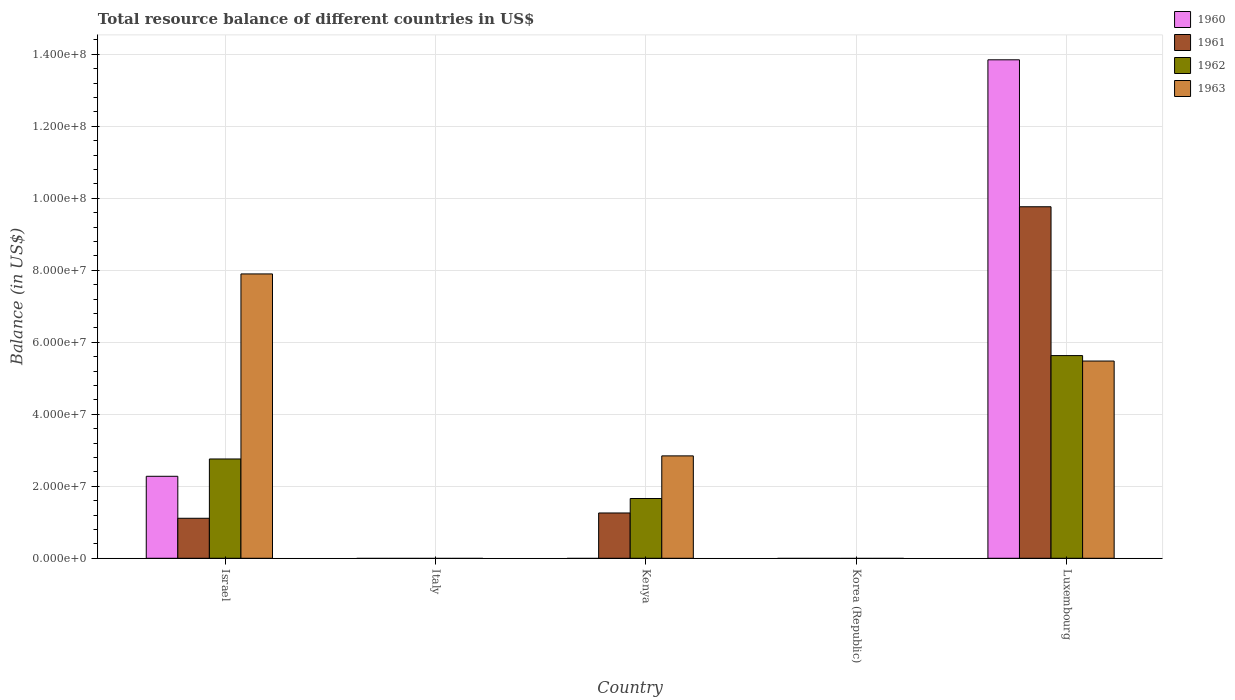Are the number of bars per tick equal to the number of legend labels?
Make the answer very short. No. What is the label of the 3rd group of bars from the left?
Provide a short and direct response. Kenya. What is the total resource balance in 1962 in Kenya?
Your answer should be very brief. 1.66e+07. Across all countries, what is the maximum total resource balance in 1962?
Keep it short and to the point. 5.63e+07. In which country was the total resource balance in 1960 maximum?
Provide a succinct answer. Luxembourg. What is the total total resource balance in 1961 in the graph?
Ensure brevity in your answer.  1.21e+08. What is the difference between the total resource balance in 1961 in Israel and that in Kenya?
Provide a short and direct response. -1.47e+06. What is the average total resource balance in 1960 per country?
Your response must be concise. 3.23e+07. What is the difference between the total resource balance of/in 1962 and total resource balance of/in 1961 in Israel?
Keep it short and to the point. 1.65e+07. What is the ratio of the total resource balance in 1963 in Kenya to that in Luxembourg?
Ensure brevity in your answer.  0.52. What is the difference between the highest and the second highest total resource balance in 1963?
Offer a terse response. 5.06e+07. What is the difference between the highest and the lowest total resource balance in 1961?
Your answer should be very brief. 9.77e+07. In how many countries, is the total resource balance in 1961 greater than the average total resource balance in 1961 taken over all countries?
Offer a terse response. 1. Is it the case that in every country, the sum of the total resource balance in 1962 and total resource balance in 1963 is greater than the sum of total resource balance in 1961 and total resource balance in 1960?
Ensure brevity in your answer.  No. Is it the case that in every country, the sum of the total resource balance in 1960 and total resource balance in 1961 is greater than the total resource balance in 1963?
Your response must be concise. No. How many bars are there?
Give a very brief answer. 11. Are all the bars in the graph horizontal?
Make the answer very short. No. How many countries are there in the graph?
Offer a terse response. 5. What is the difference between two consecutive major ticks on the Y-axis?
Your response must be concise. 2.00e+07. Are the values on the major ticks of Y-axis written in scientific E-notation?
Your answer should be compact. Yes. Does the graph contain any zero values?
Your answer should be very brief. Yes. Does the graph contain grids?
Your response must be concise. Yes. How many legend labels are there?
Provide a short and direct response. 4. What is the title of the graph?
Provide a short and direct response. Total resource balance of different countries in US$. What is the label or title of the X-axis?
Your answer should be very brief. Country. What is the label or title of the Y-axis?
Offer a very short reply. Balance (in US$). What is the Balance (in US$) in 1960 in Israel?
Give a very brief answer. 2.28e+07. What is the Balance (in US$) of 1961 in Israel?
Ensure brevity in your answer.  1.11e+07. What is the Balance (in US$) in 1962 in Israel?
Offer a terse response. 2.76e+07. What is the Balance (in US$) of 1963 in Israel?
Provide a short and direct response. 7.90e+07. What is the Balance (in US$) in 1961 in Italy?
Your response must be concise. 0. What is the Balance (in US$) of 1963 in Italy?
Offer a very short reply. 0. What is the Balance (in US$) of 1961 in Kenya?
Your answer should be compact. 1.26e+07. What is the Balance (in US$) in 1962 in Kenya?
Your answer should be very brief. 1.66e+07. What is the Balance (in US$) in 1963 in Kenya?
Ensure brevity in your answer.  2.84e+07. What is the Balance (in US$) of 1963 in Korea (Republic)?
Give a very brief answer. 0. What is the Balance (in US$) of 1960 in Luxembourg?
Your answer should be very brief. 1.38e+08. What is the Balance (in US$) in 1961 in Luxembourg?
Offer a terse response. 9.77e+07. What is the Balance (in US$) of 1962 in Luxembourg?
Provide a succinct answer. 5.63e+07. What is the Balance (in US$) of 1963 in Luxembourg?
Keep it short and to the point. 5.48e+07. Across all countries, what is the maximum Balance (in US$) in 1960?
Your answer should be compact. 1.38e+08. Across all countries, what is the maximum Balance (in US$) in 1961?
Offer a very short reply. 9.77e+07. Across all countries, what is the maximum Balance (in US$) in 1962?
Provide a succinct answer. 5.63e+07. Across all countries, what is the maximum Balance (in US$) of 1963?
Your answer should be very brief. 7.90e+07. Across all countries, what is the minimum Balance (in US$) of 1960?
Offer a terse response. 0. Across all countries, what is the minimum Balance (in US$) in 1962?
Your answer should be compact. 0. Across all countries, what is the minimum Balance (in US$) in 1963?
Your answer should be very brief. 0. What is the total Balance (in US$) in 1960 in the graph?
Provide a short and direct response. 1.61e+08. What is the total Balance (in US$) in 1961 in the graph?
Offer a terse response. 1.21e+08. What is the total Balance (in US$) of 1962 in the graph?
Ensure brevity in your answer.  1.01e+08. What is the total Balance (in US$) in 1963 in the graph?
Provide a short and direct response. 1.62e+08. What is the difference between the Balance (in US$) of 1961 in Israel and that in Kenya?
Offer a terse response. -1.47e+06. What is the difference between the Balance (in US$) in 1962 in Israel and that in Kenya?
Provide a succinct answer. 1.10e+07. What is the difference between the Balance (in US$) of 1963 in Israel and that in Kenya?
Offer a terse response. 5.06e+07. What is the difference between the Balance (in US$) of 1960 in Israel and that in Luxembourg?
Keep it short and to the point. -1.16e+08. What is the difference between the Balance (in US$) of 1961 in Israel and that in Luxembourg?
Offer a terse response. -8.66e+07. What is the difference between the Balance (in US$) in 1962 in Israel and that in Luxembourg?
Your response must be concise. -2.87e+07. What is the difference between the Balance (in US$) of 1963 in Israel and that in Luxembourg?
Offer a terse response. 2.42e+07. What is the difference between the Balance (in US$) in 1961 in Kenya and that in Luxembourg?
Provide a succinct answer. -8.51e+07. What is the difference between the Balance (in US$) in 1962 in Kenya and that in Luxembourg?
Offer a terse response. -3.97e+07. What is the difference between the Balance (in US$) in 1963 in Kenya and that in Luxembourg?
Your answer should be very brief. -2.64e+07. What is the difference between the Balance (in US$) of 1960 in Israel and the Balance (in US$) of 1961 in Kenya?
Provide a short and direct response. 1.02e+07. What is the difference between the Balance (in US$) in 1960 in Israel and the Balance (in US$) in 1962 in Kenya?
Offer a terse response. 6.17e+06. What is the difference between the Balance (in US$) of 1960 in Israel and the Balance (in US$) of 1963 in Kenya?
Offer a very short reply. -5.67e+06. What is the difference between the Balance (in US$) of 1961 in Israel and the Balance (in US$) of 1962 in Kenya?
Your response must be concise. -5.49e+06. What is the difference between the Balance (in US$) in 1961 in Israel and the Balance (in US$) in 1963 in Kenya?
Provide a short and direct response. -1.73e+07. What is the difference between the Balance (in US$) of 1962 in Israel and the Balance (in US$) of 1963 in Kenya?
Give a very brief answer. -8.62e+05. What is the difference between the Balance (in US$) in 1960 in Israel and the Balance (in US$) in 1961 in Luxembourg?
Your answer should be very brief. -7.49e+07. What is the difference between the Balance (in US$) in 1960 in Israel and the Balance (in US$) in 1962 in Luxembourg?
Your answer should be compact. -3.35e+07. What is the difference between the Balance (in US$) of 1960 in Israel and the Balance (in US$) of 1963 in Luxembourg?
Your answer should be very brief. -3.20e+07. What is the difference between the Balance (in US$) of 1961 in Israel and the Balance (in US$) of 1962 in Luxembourg?
Your answer should be very brief. -4.52e+07. What is the difference between the Balance (in US$) in 1961 in Israel and the Balance (in US$) in 1963 in Luxembourg?
Make the answer very short. -4.37e+07. What is the difference between the Balance (in US$) of 1962 in Israel and the Balance (in US$) of 1963 in Luxembourg?
Provide a succinct answer. -2.72e+07. What is the difference between the Balance (in US$) of 1961 in Kenya and the Balance (in US$) of 1962 in Luxembourg?
Make the answer very short. -4.37e+07. What is the difference between the Balance (in US$) of 1961 in Kenya and the Balance (in US$) of 1963 in Luxembourg?
Offer a terse response. -4.22e+07. What is the difference between the Balance (in US$) of 1962 in Kenya and the Balance (in US$) of 1963 in Luxembourg?
Your answer should be compact. -3.82e+07. What is the average Balance (in US$) in 1960 per country?
Provide a succinct answer. 3.23e+07. What is the average Balance (in US$) in 1961 per country?
Provide a succinct answer. 2.43e+07. What is the average Balance (in US$) of 1962 per country?
Give a very brief answer. 2.01e+07. What is the average Balance (in US$) in 1963 per country?
Offer a terse response. 3.24e+07. What is the difference between the Balance (in US$) of 1960 and Balance (in US$) of 1961 in Israel?
Offer a terse response. 1.17e+07. What is the difference between the Balance (in US$) in 1960 and Balance (in US$) in 1962 in Israel?
Provide a short and direct response. -4.81e+06. What is the difference between the Balance (in US$) of 1960 and Balance (in US$) of 1963 in Israel?
Your response must be concise. -5.62e+07. What is the difference between the Balance (in US$) in 1961 and Balance (in US$) in 1962 in Israel?
Offer a very short reply. -1.65e+07. What is the difference between the Balance (in US$) of 1961 and Balance (in US$) of 1963 in Israel?
Provide a short and direct response. -6.79e+07. What is the difference between the Balance (in US$) of 1962 and Balance (in US$) of 1963 in Israel?
Your answer should be very brief. -5.14e+07. What is the difference between the Balance (in US$) of 1961 and Balance (in US$) of 1962 in Kenya?
Your response must be concise. -4.02e+06. What is the difference between the Balance (in US$) in 1961 and Balance (in US$) in 1963 in Kenya?
Give a very brief answer. -1.59e+07. What is the difference between the Balance (in US$) in 1962 and Balance (in US$) in 1963 in Kenya?
Make the answer very short. -1.18e+07. What is the difference between the Balance (in US$) in 1960 and Balance (in US$) in 1961 in Luxembourg?
Your response must be concise. 4.08e+07. What is the difference between the Balance (in US$) in 1960 and Balance (in US$) in 1962 in Luxembourg?
Your answer should be very brief. 8.22e+07. What is the difference between the Balance (in US$) in 1960 and Balance (in US$) in 1963 in Luxembourg?
Provide a short and direct response. 8.37e+07. What is the difference between the Balance (in US$) in 1961 and Balance (in US$) in 1962 in Luxembourg?
Provide a short and direct response. 4.13e+07. What is the difference between the Balance (in US$) of 1961 and Balance (in US$) of 1963 in Luxembourg?
Your answer should be compact. 4.29e+07. What is the difference between the Balance (in US$) in 1962 and Balance (in US$) in 1963 in Luxembourg?
Make the answer very short. 1.52e+06. What is the ratio of the Balance (in US$) of 1961 in Israel to that in Kenya?
Your answer should be compact. 0.88. What is the ratio of the Balance (in US$) in 1962 in Israel to that in Kenya?
Your answer should be very brief. 1.66. What is the ratio of the Balance (in US$) of 1963 in Israel to that in Kenya?
Offer a terse response. 2.78. What is the ratio of the Balance (in US$) in 1960 in Israel to that in Luxembourg?
Offer a terse response. 0.16. What is the ratio of the Balance (in US$) in 1961 in Israel to that in Luxembourg?
Provide a short and direct response. 0.11. What is the ratio of the Balance (in US$) in 1962 in Israel to that in Luxembourg?
Your answer should be very brief. 0.49. What is the ratio of the Balance (in US$) of 1963 in Israel to that in Luxembourg?
Keep it short and to the point. 1.44. What is the ratio of the Balance (in US$) of 1961 in Kenya to that in Luxembourg?
Give a very brief answer. 0.13. What is the ratio of the Balance (in US$) in 1962 in Kenya to that in Luxembourg?
Your answer should be compact. 0.29. What is the ratio of the Balance (in US$) in 1963 in Kenya to that in Luxembourg?
Provide a short and direct response. 0.52. What is the difference between the highest and the second highest Balance (in US$) of 1961?
Make the answer very short. 8.51e+07. What is the difference between the highest and the second highest Balance (in US$) of 1962?
Your answer should be very brief. 2.87e+07. What is the difference between the highest and the second highest Balance (in US$) of 1963?
Offer a very short reply. 2.42e+07. What is the difference between the highest and the lowest Balance (in US$) in 1960?
Your response must be concise. 1.38e+08. What is the difference between the highest and the lowest Balance (in US$) of 1961?
Ensure brevity in your answer.  9.77e+07. What is the difference between the highest and the lowest Balance (in US$) in 1962?
Provide a succinct answer. 5.63e+07. What is the difference between the highest and the lowest Balance (in US$) in 1963?
Offer a very short reply. 7.90e+07. 